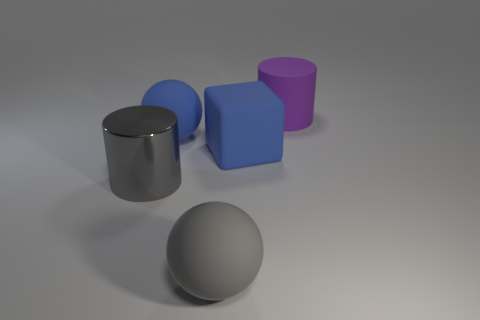There is a cylinder left of the blue block; what number of large gray objects are on the right side of it?
Ensure brevity in your answer.  1. Are there more big cylinders than large objects?
Your response must be concise. No. Is there a big metal object that has the same color as the large matte cylinder?
Ensure brevity in your answer.  No. Do the cylinder that is right of the gray metal thing and the big gray sphere have the same size?
Offer a terse response. Yes. Is the number of tiny purple things less than the number of big matte cylinders?
Make the answer very short. Yes. Is there a object made of the same material as the blue cube?
Make the answer very short. Yes. What is the shape of the large gray rubber thing that is in front of the large gray cylinder?
Make the answer very short. Sphere. Is the color of the ball in front of the large gray cylinder the same as the big shiny cylinder?
Your response must be concise. Yes. Are there fewer large matte things to the left of the gray metal cylinder than cubes?
Offer a terse response. Yes. There is another sphere that is made of the same material as the blue ball; what color is it?
Ensure brevity in your answer.  Gray. 